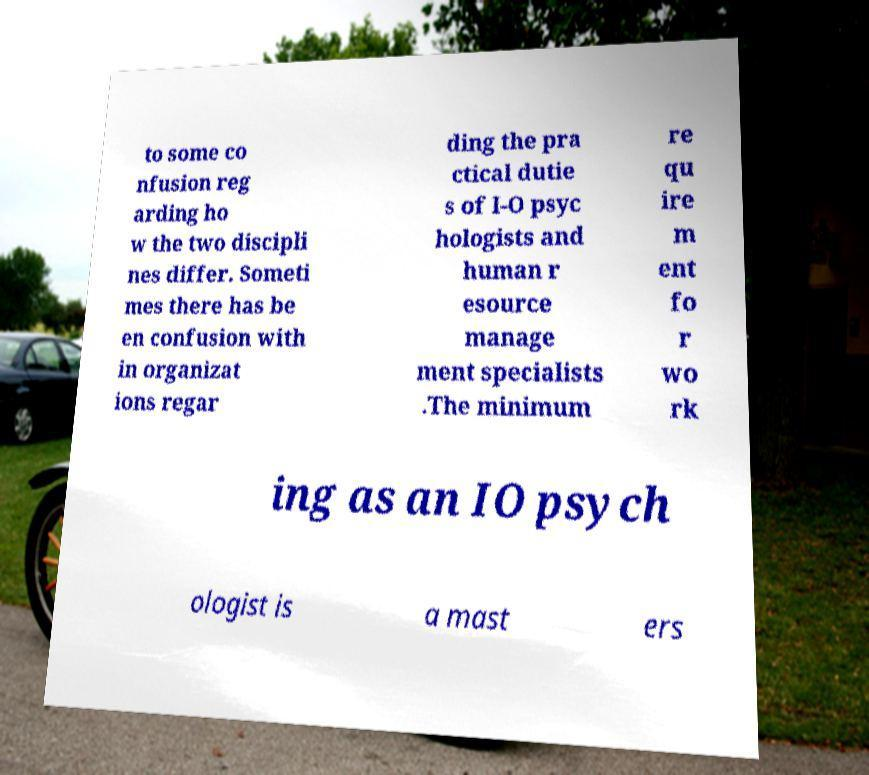Please identify and transcribe the text found in this image. to some co nfusion reg arding ho w the two discipli nes differ. Someti mes there has be en confusion with in organizat ions regar ding the pra ctical dutie s of I-O psyc hologists and human r esource manage ment specialists .The minimum re qu ire m ent fo r wo rk ing as an IO psych ologist is a mast ers 